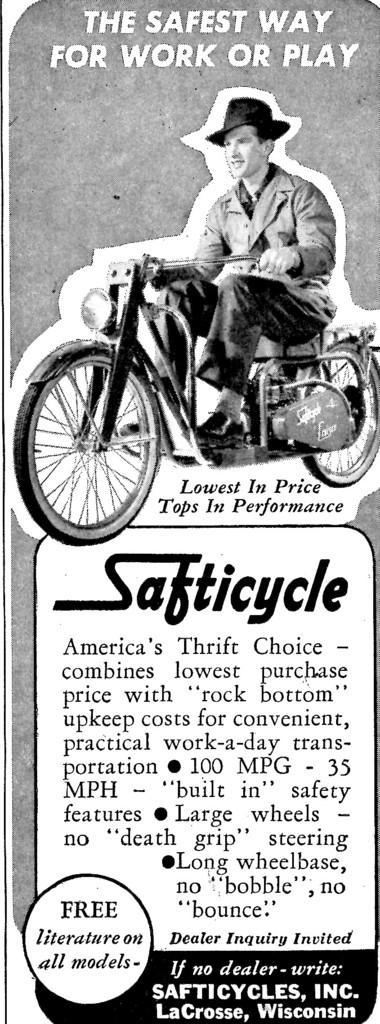Describe this image in one or two sentences. In this image I can see the article. 